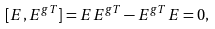<formula> <loc_0><loc_0><loc_500><loc_500>[ E , E ^ { g T } ] = E E ^ { g T } - E ^ { g T } E = 0 ,</formula> 